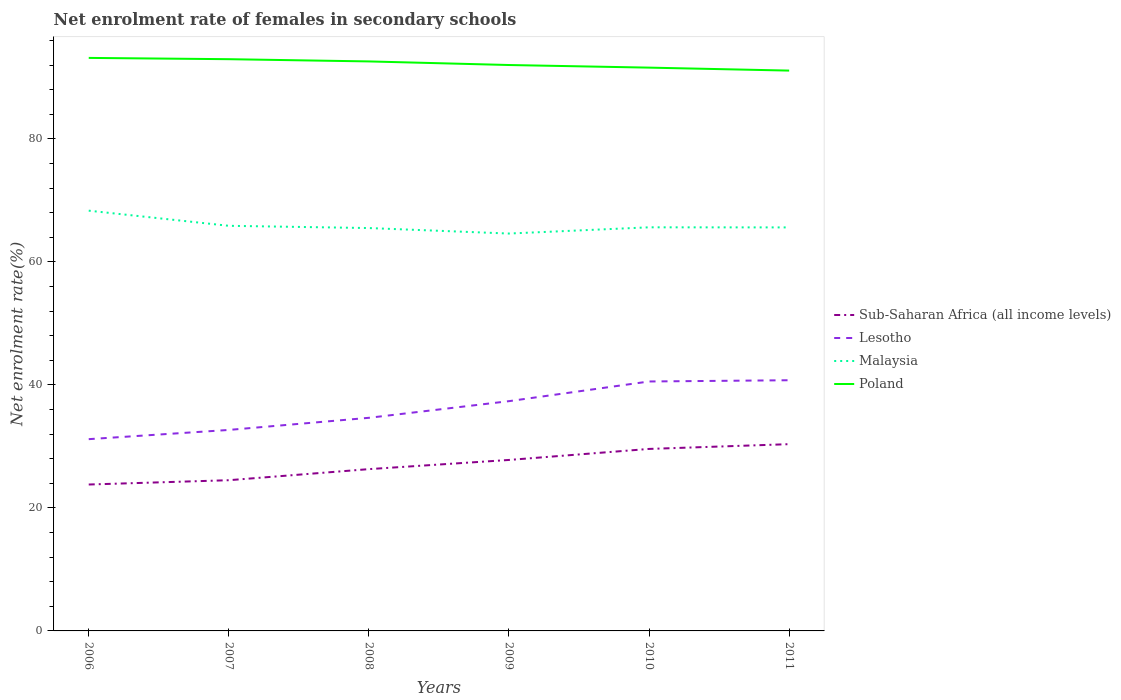How many different coloured lines are there?
Your answer should be very brief. 4. Is the number of lines equal to the number of legend labels?
Your answer should be compact. Yes. Across all years, what is the maximum net enrolment rate of females in secondary schools in Malaysia?
Keep it short and to the point. 64.6. What is the total net enrolment rate of females in secondary schools in Sub-Saharan Africa (all income levels) in the graph?
Your answer should be very brief. -1.49. What is the difference between the highest and the second highest net enrolment rate of females in secondary schools in Poland?
Your answer should be compact. 2.06. Is the net enrolment rate of females in secondary schools in Poland strictly greater than the net enrolment rate of females in secondary schools in Malaysia over the years?
Provide a succinct answer. No. Does the graph contain any zero values?
Give a very brief answer. No. Does the graph contain grids?
Provide a short and direct response. No. Where does the legend appear in the graph?
Provide a short and direct response. Center right. How many legend labels are there?
Keep it short and to the point. 4. What is the title of the graph?
Ensure brevity in your answer.  Net enrolment rate of females in secondary schools. What is the label or title of the X-axis?
Offer a terse response. Years. What is the label or title of the Y-axis?
Make the answer very short. Net enrolment rate(%). What is the Net enrolment rate(%) in Sub-Saharan Africa (all income levels) in 2006?
Your answer should be very brief. 23.8. What is the Net enrolment rate(%) in Lesotho in 2006?
Your answer should be very brief. 31.17. What is the Net enrolment rate(%) of Malaysia in 2006?
Your answer should be very brief. 68.32. What is the Net enrolment rate(%) of Poland in 2006?
Offer a terse response. 93.15. What is the Net enrolment rate(%) in Sub-Saharan Africa (all income levels) in 2007?
Offer a terse response. 24.5. What is the Net enrolment rate(%) of Lesotho in 2007?
Your answer should be compact. 32.67. What is the Net enrolment rate(%) in Malaysia in 2007?
Provide a short and direct response. 65.86. What is the Net enrolment rate(%) in Poland in 2007?
Your response must be concise. 92.95. What is the Net enrolment rate(%) of Sub-Saharan Africa (all income levels) in 2008?
Offer a very short reply. 26.3. What is the Net enrolment rate(%) of Lesotho in 2008?
Your answer should be compact. 34.65. What is the Net enrolment rate(%) in Malaysia in 2008?
Keep it short and to the point. 65.49. What is the Net enrolment rate(%) of Poland in 2008?
Provide a short and direct response. 92.58. What is the Net enrolment rate(%) of Sub-Saharan Africa (all income levels) in 2009?
Make the answer very short. 27.79. What is the Net enrolment rate(%) of Lesotho in 2009?
Your answer should be compact. 37.35. What is the Net enrolment rate(%) in Malaysia in 2009?
Ensure brevity in your answer.  64.6. What is the Net enrolment rate(%) in Poland in 2009?
Offer a very short reply. 92. What is the Net enrolment rate(%) in Sub-Saharan Africa (all income levels) in 2010?
Provide a succinct answer. 29.59. What is the Net enrolment rate(%) of Lesotho in 2010?
Your response must be concise. 40.55. What is the Net enrolment rate(%) of Malaysia in 2010?
Offer a very short reply. 65.61. What is the Net enrolment rate(%) in Poland in 2010?
Your answer should be very brief. 91.57. What is the Net enrolment rate(%) in Sub-Saharan Africa (all income levels) in 2011?
Keep it short and to the point. 30.36. What is the Net enrolment rate(%) in Lesotho in 2011?
Give a very brief answer. 40.75. What is the Net enrolment rate(%) of Malaysia in 2011?
Keep it short and to the point. 65.6. What is the Net enrolment rate(%) of Poland in 2011?
Your answer should be very brief. 91.09. Across all years, what is the maximum Net enrolment rate(%) in Sub-Saharan Africa (all income levels)?
Your answer should be very brief. 30.36. Across all years, what is the maximum Net enrolment rate(%) of Lesotho?
Your response must be concise. 40.75. Across all years, what is the maximum Net enrolment rate(%) of Malaysia?
Provide a short and direct response. 68.32. Across all years, what is the maximum Net enrolment rate(%) in Poland?
Provide a short and direct response. 93.15. Across all years, what is the minimum Net enrolment rate(%) in Sub-Saharan Africa (all income levels)?
Offer a very short reply. 23.8. Across all years, what is the minimum Net enrolment rate(%) in Lesotho?
Your answer should be very brief. 31.17. Across all years, what is the minimum Net enrolment rate(%) of Malaysia?
Ensure brevity in your answer.  64.6. Across all years, what is the minimum Net enrolment rate(%) in Poland?
Your answer should be compact. 91.09. What is the total Net enrolment rate(%) of Sub-Saharan Africa (all income levels) in the graph?
Make the answer very short. 162.35. What is the total Net enrolment rate(%) of Lesotho in the graph?
Offer a terse response. 217.15. What is the total Net enrolment rate(%) of Malaysia in the graph?
Make the answer very short. 395.48. What is the total Net enrolment rate(%) of Poland in the graph?
Give a very brief answer. 553.35. What is the difference between the Net enrolment rate(%) in Sub-Saharan Africa (all income levels) in 2006 and that in 2007?
Your answer should be very brief. -0.7. What is the difference between the Net enrolment rate(%) in Lesotho in 2006 and that in 2007?
Offer a terse response. -1.5. What is the difference between the Net enrolment rate(%) of Malaysia in 2006 and that in 2007?
Offer a terse response. 2.46. What is the difference between the Net enrolment rate(%) of Poland in 2006 and that in 2007?
Provide a short and direct response. 0.21. What is the difference between the Net enrolment rate(%) in Sub-Saharan Africa (all income levels) in 2006 and that in 2008?
Offer a terse response. -2.5. What is the difference between the Net enrolment rate(%) in Lesotho in 2006 and that in 2008?
Your answer should be compact. -3.47. What is the difference between the Net enrolment rate(%) in Malaysia in 2006 and that in 2008?
Your answer should be very brief. 2.83. What is the difference between the Net enrolment rate(%) of Poland in 2006 and that in 2008?
Give a very brief answer. 0.57. What is the difference between the Net enrolment rate(%) of Sub-Saharan Africa (all income levels) in 2006 and that in 2009?
Make the answer very short. -3.99. What is the difference between the Net enrolment rate(%) in Lesotho in 2006 and that in 2009?
Your answer should be very brief. -6.18. What is the difference between the Net enrolment rate(%) in Malaysia in 2006 and that in 2009?
Your response must be concise. 3.72. What is the difference between the Net enrolment rate(%) of Poland in 2006 and that in 2009?
Provide a succinct answer. 1.16. What is the difference between the Net enrolment rate(%) of Sub-Saharan Africa (all income levels) in 2006 and that in 2010?
Keep it short and to the point. -5.79. What is the difference between the Net enrolment rate(%) of Lesotho in 2006 and that in 2010?
Make the answer very short. -9.38. What is the difference between the Net enrolment rate(%) in Malaysia in 2006 and that in 2010?
Provide a succinct answer. 2.71. What is the difference between the Net enrolment rate(%) of Poland in 2006 and that in 2010?
Your answer should be compact. 1.58. What is the difference between the Net enrolment rate(%) of Sub-Saharan Africa (all income levels) in 2006 and that in 2011?
Your response must be concise. -6.56. What is the difference between the Net enrolment rate(%) in Lesotho in 2006 and that in 2011?
Offer a very short reply. -9.58. What is the difference between the Net enrolment rate(%) in Malaysia in 2006 and that in 2011?
Your response must be concise. 2.72. What is the difference between the Net enrolment rate(%) in Poland in 2006 and that in 2011?
Ensure brevity in your answer.  2.06. What is the difference between the Net enrolment rate(%) in Sub-Saharan Africa (all income levels) in 2007 and that in 2008?
Provide a succinct answer. -1.8. What is the difference between the Net enrolment rate(%) in Lesotho in 2007 and that in 2008?
Ensure brevity in your answer.  -1.97. What is the difference between the Net enrolment rate(%) in Malaysia in 2007 and that in 2008?
Ensure brevity in your answer.  0.37. What is the difference between the Net enrolment rate(%) in Poland in 2007 and that in 2008?
Your answer should be very brief. 0.36. What is the difference between the Net enrolment rate(%) of Sub-Saharan Africa (all income levels) in 2007 and that in 2009?
Make the answer very short. -3.29. What is the difference between the Net enrolment rate(%) of Lesotho in 2007 and that in 2009?
Your response must be concise. -4.68. What is the difference between the Net enrolment rate(%) in Malaysia in 2007 and that in 2009?
Ensure brevity in your answer.  1.26. What is the difference between the Net enrolment rate(%) of Poland in 2007 and that in 2009?
Provide a short and direct response. 0.95. What is the difference between the Net enrolment rate(%) of Sub-Saharan Africa (all income levels) in 2007 and that in 2010?
Provide a short and direct response. -5.09. What is the difference between the Net enrolment rate(%) of Lesotho in 2007 and that in 2010?
Your answer should be very brief. -7.88. What is the difference between the Net enrolment rate(%) in Malaysia in 2007 and that in 2010?
Make the answer very short. 0.25. What is the difference between the Net enrolment rate(%) in Poland in 2007 and that in 2010?
Your response must be concise. 1.37. What is the difference between the Net enrolment rate(%) of Sub-Saharan Africa (all income levels) in 2007 and that in 2011?
Keep it short and to the point. -5.86. What is the difference between the Net enrolment rate(%) of Lesotho in 2007 and that in 2011?
Your response must be concise. -8.08. What is the difference between the Net enrolment rate(%) of Malaysia in 2007 and that in 2011?
Your response must be concise. 0.26. What is the difference between the Net enrolment rate(%) of Poland in 2007 and that in 2011?
Your answer should be compact. 1.85. What is the difference between the Net enrolment rate(%) of Sub-Saharan Africa (all income levels) in 2008 and that in 2009?
Your answer should be very brief. -1.49. What is the difference between the Net enrolment rate(%) of Lesotho in 2008 and that in 2009?
Your answer should be compact. -2.71. What is the difference between the Net enrolment rate(%) of Malaysia in 2008 and that in 2009?
Your response must be concise. 0.89. What is the difference between the Net enrolment rate(%) of Poland in 2008 and that in 2009?
Offer a terse response. 0.58. What is the difference between the Net enrolment rate(%) in Sub-Saharan Africa (all income levels) in 2008 and that in 2010?
Offer a terse response. -3.28. What is the difference between the Net enrolment rate(%) of Lesotho in 2008 and that in 2010?
Your answer should be compact. -5.91. What is the difference between the Net enrolment rate(%) in Malaysia in 2008 and that in 2010?
Provide a succinct answer. -0.12. What is the difference between the Net enrolment rate(%) in Poland in 2008 and that in 2010?
Provide a short and direct response. 1.01. What is the difference between the Net enrolment rate(%) of Sub-Saharan Africa (all income levels) in 2008 and that in 2011?
Give a very brief answer. -4.06. What is the difference between the Net enrolment rate(%) of Lesotho in 2008 and that in 2011?
Your response must be concise. -6.11. What is the difference between the Net enrolment rate(%) in Malaysia in 2008 and that in 2011?
Keep it short and to the point. -0.1. What is the difference between the Net enrolment rate(%) of Poland in 2008 and that in 2011?
Your answer should be very brief. 1.49. What is the difference between the Net enrolment rate(%) in Sub-Saharan Africa (all income levels) in 2009 and that in 2010?
Ensure brevity in your answer.  -1.79. What is the difference between the Net enrolment rate(%) in Lesotho in 2009 and that in 2010?
Provide a short and direct response. -3.2. What is the difference between the Net enrolment rate(%) of Malaysia in 2009 and that in 2010?
Make the answer very short. -1.01. What is the difference between the Net enrolment rate(%) of Poland in 2009 and that in 2010?
Your response must be concise. 0.42. What is the difference between the Net enrolment rate(%) in Sub-Saharan Africa (all income levels) in 2009 and that in 2011?
Ensure brevity in your answer.  -2.57. What is the difference between the Net enrolment rate(%) of Lesotho in 2009 and that in 2011?
Your response must be concise. -3.4. What is the difference between the Net enrolment rate(%) in Malaysia in 2009 and that in 2011?
Your answer should be very brief. -1. What is the difference between the Net enrolment rate(%) in Poland in 2009 and that in 2011?
Your answer should be very brief. 0.91. What is the difference between the Net enrolment rate(%) in Sub-Saharan Africa (all income levels) in 2010 and that in 2011?
Provide a succinct answer. -0.78. What is the difference between the Net enrolment rate(%) of Lesotho in 2010 and that in 2011?
Offer a terse response. -0.2. What is the difference between the Net enrolment rate(%) of Malaysia in 2010 and that in 2011?
Make the answer very short. 0.02. What is the difference between the Net enrolment rate(%) in Poland in 2010 and that in 2011?
Make the answer very short. 0.48. What is the difference between the Net enrolment rate(%) in Sub-Saharan Africa (all income levels) in 2006 and the Net enrolment rate(%) in Lesotho in 2007?
Make the answer very short. -8.87. What is the difference between the Net enrolment rate(%) of Sub-Saharan Africa (all income levels) in 2006 and the Net enrolment rate(%) of Malaysia in 2007?
Keep it short and to the point. -42.06. What is the difference between the Net enrolment rate(%) of Sub-Saharan Africa (all income levels) in 2006 and the Net enrolment rate(%) of Poland in 2007?
Your answer should be compact. -69.14. What is the difference between the Net enrolment rate(%) of Lesotho in 2006 and the Net enrolment rate(%) of Malaysia in 2007?
Provide a succinct answer. -34.68. What is the difference between the Net enrolment rate(%) in Lesotho in 2006 and the Net enrolment rate(%) in Poland in 2007?
Your response must be concise. -61.77. What is the difference between the Net enrolment rate(%) of Malaysia in 2006 and the Net enrolment rate(%) of Poland in 2007?
Provide a short and direct response. -24.63. What is the difference between the Net enrolment rate(%) of Sub-Saharan Africa (all income levels) in 2006 and the Net enrolment rate(%) of Lesotho in 2008?
Your answer should be very brief. -10.85. What is the difference between the Net enrolment rate(%) in Sub-Saharan Africa (all income levels) in 2006 and the Net enrolment rate(%) in Malaysia in 2008?
Keep it short and to the point. -41.69. What is the difference between the Net enrolment rate(%) of Sub-Saharan Africa (all income levels) in 2006 and the Net enrolment rate(%) of Poland in 2008?
Offer a terse response. -68.78. What is the difference between the Net enrolment rate(%) in Lesotho in 2006 and the Net enrolment rate(%) in Malaysia in 2008?
Your response must be concise. -34.32. What is the difference between the Net enrolment rate(%) of Lesotho in 2006 and the Net enrolment rate(%) of Poland in 2008?
Your response must be concise. -61.41. What is the difference between the Net enrolment rate(%) in Malaysia in 2006 and the Net enrolment rate(%) in Poland in 2008?
Provide a succinct answer. -24.26. What is the difference between the Net enrolment rate(%) in Sub-Saharan Africa (all income levels) in 2006 and the Net enrolment rate(%) in Lesotho in 2009?
Provide a short and direct response. -13.55. What is the difference between the Net enrolment rate(%) of Sub-Saharan Africa (all income levels) in 2006 and the Net enrolment rate(%) of Malaysia in 2009?
Give a very brief answer. -40.8. What is the difference between the Net enrolment rate(%) in Sub-Saharan Africa (all income levels) in 2006 and the Net enrolment rate(%) in Poland in 2009?
Your response must be concise. -68.2. What is the difference between the Net enrolment rate(%) in Lesotho in 2006 and the Net enrolment rate(%) in Malaysia in 2009?
Give a very brief answer. -33.43. What is the difference between the Net enrolment rate(%) of Lesotho in 2006 and the Net enrolment rate(%) of Poland in 2009?
Your answer should be very brief. -60.82. What is the difference between the Net enrolment rate(%) in Malaysia in 2006 and the Net enrolment rate(%) in Poland in 2009?
Your response must be concise. -23.68. What is the difference between the Net enrolment rate(%) in Sub-Saharan Africa (all income levels) in 2006 and the Net enrolment rate(%) in Lesotho in 2010?
Your answer should be very brief. -16.75. What is the difference between the Net enrolment rate(%) of Sub-Saharan Africa (all income levels) in 2006 and the Net enrolment rate(%) of Malaysia in 2010?
Provide a succinct answer. -41.81. What is the difference between the Net enrolment rate(%) of Sub-Saharan Africa (all income levels) in 2006 and the Net enrolment rate(%) of Poland in 2010?
Offer a very short reply. -67.77. What is the difference between the Net enrolment rate(%) of Lesotho in 2006 and the Net enrolment rate(%) of Malaysia in 2010?
Provide a succinct answer. -34.44. What is the difference between the Net enrolment rate(%) of Lesotho in 2006 and the Net enrolment rate(%) of Poland in 2010?
Your answer should be compact. -60.4. What is the difference between the Net enrolment rate(%) in Malaysia in 2006 and the Net enrolment rate(%) in Poland in 2010?
Provide a short and direct response. -23.25. What is the difference between the Net enrolment rate(%) in Sub-Saharan Africa (all income levels) in 2006 and the Net enrolment rate(%) in Lesotho in 2011?
Keep it short and to the point. -16.95. What is the difference between the Net enrolment rate(%) in Sub-Saharan Africa (all income levels) in 2006 and the Net enrolment rate(%) in Malaysia in 2011?
Your response must be concise. -41.8. What is the difference between the Net enrolment rate(%) in Sub-Saharan Africa (all income levels) in 2006 and the Net enrolment rate(%) in Poland in 2011?
Your answer should be very brief. -67.29. What is the difference between the Net enrolment rate(%) of Lesotho in 2006 and the Net enrolment rate(%) of Malaysia in 2011?
Provide a short and direct response. -34.42. What is the difference between the Net enrolment rate(%) in Lesotho in 2006 and the Net enrolment rate(%) in Poland in 2011?
Provide a succinct answer. -59.92. What is the difference between the Net enrolment rate(%) in Malaysia in 2006 and the Net enrolment rate(%) in Poland in 2011?
Your answer should be compact. -22.77. What is the difference between the Net enrolment rate(%) in Sub-Saharan Africa (all income levels) in 2007 and the Net enrolment rate(%) in Lesotho in 2008?
Provide a succinct answer. -10.14. What is the difference between the Net enrolment rate(%) in Sub-Saharan Africa (all income levels) in 2007 and the Net enrolment rate(%) in Malaysia in 2008?
Your response must be concise. -40.99. What is the difference between the Net enrolment rate(%) in Sub-Saharan Africa (all income levels) in 2007 and the Net enrolment rate(%) in Poland in 2008?
Offer a terse response. -68.08. What is the difference between the Net enrolment rate(%) of Lesotho in 2007 and the Net enrolment rate(%) of Malaysia in 2008?
Provide a succinct answer. -32.82. What is the difference between the Net enrolment rate(%) in Lesotho in 2007 and the Net enrolment rate(%) in Poland in 2008?
Keep it short and to the point. -59.91. What is the difference between the Net enrolment rate(%) in Malaysia in 2007 and the Net enrolment rate(%) in Poland in 2008?
Your answer should be compact. -26.72. What is the difference between the Net enrolment rate(%) of Sub-Saharan Africa (all income levels) in 2007 and the Net enrolment rate(%) of Lesotho in 2009?
Your answer should be compact. -12.85. What is the difference between the Net enrolment rate(%) of Sub-Saharan Africa (all income levels) in 2007 and the Net enrolment rate(%) of Malaysia in 2009?
Your answer should be very brief. -40.1. What is the difference between the Net enrolment rate(%) in Sub-Saharan Africa (all income levels) in 2007 and the Net enrolment rate(%) in Poland in 2009?
Ensure brevity in your answer.  -67.5. What is the difference between the Net enrolment rate(%) of Lesotho in 2007 and the Net enrolment rate(%) of Malaysia in 2009?
Keep it short and to the point. -31.93. What is the difference between the Net enrolment rate(%) in Lesotho in 2007 and the Net enrolment rate(%) in Poland in 2009?
Provide a succinct answer. -59.32. What is the difference between the Net enrolment rate(%) of Malaysia in 2007 and the Net enrolment rate(%) of Poland in 2009?
Provide a succinct answer. -26.14. What is the difference between the Net enrolment rate(%) of Sub-Saharan Africa (all income levels) in 2007 and the Net enrolment rate(%) of Lesotho in 2010?
Provide a succinct answer. -16.05. What is the difference between the Net enrolment rate(%) of Sub-Saharan Africa (all income levels) in 2007 and the Net enrolment rate(%) of Malaysia in 2010?
Your answer should be very brief. -41.11. What is the difference between the Net enrolment rate(%) of Sub-Saharan Africa (all income levels) in 2007 and the Net enrolment rate(%) of Poland in 2010?
Provide a short and direct response. -67.07. What is the difference between the Net enrolment rate(%) of Lesotho in 2007 and the Net enrolment rate(%) of Malaysia in 2010?
Make the answer very short. -32.94. What is the difference between the Net enrolment rate(%) in Lesotho in 2007 and the Net enrolment rate(%) in Poland in 2010?
Your answer should be very brief. -58.9. What is the difference between the Net enrolment rate(%) of Malaysia in 2007 and the Net enrolment rate(%) of Poland in 2010?
Offer a terse response. -25.71. What is the difference between the Net enrolment rate(%) of Sub-Saharan Africa (all income levels) in 2007 and the Net enrolment rate(%) of Lesotho in 2011?
Offer a very short reply. -16.25. What is the difference between the Net enrolment rate(%) of Sub-Saharan Africa (all income levels) in 2007 and the Net enrolment rate(%) of Malaysia in 2011?
Keep it short and to the point. -41.1. What is the difference between the Net enrolment rate(%) in Sub-Saharan Africa (all income levels) in 2007 and the Net enrolment rate(%) in Poland in 2011?
Offer a very short reply. -66.59. What is the difference between the Net enrolment rate(%) of Lesotho in 2007 and the Net enrolment rate(%) of Malaysia in 2011?
Keep it short and to the point. -32.92. What is the difference between the Net enrolment rate(%) of Lesotho in 2007 and the Net enrolment rate(%) of Poland in 2011?
Provide a succinct answer. -58.42. What is the difference between the Net enrolment rate(%) of Malaysia in 2007 and the Net enrolment rate(%) of Poland in 2011?
Offer a very short reply. -25.23. What is the difference between the Net enrolment rate(%) of Sub-Saharan Africa (all income levels) in 2008 and the Net enrolment rate(%) of Lesotho in 2009?
Your response must be concise. -11.05. What is the difference between the Net enrolment rate(%) in Sub-Saharan Africa (all income levels) in 2008 and the Net enrolment rate(%) in Malaysia in 2009?
Give a very brief answer. -38.3. What is the difference between the Net enrolment rate(%) in Sub-Saharan Africa (all income levels) in 2008 and the Net enrolment rate(%) in Poland in 2009?
Offer a terse response. -65.7. What is the difference between the Net enrolment rate(%) of Lesotho in 2008 and the Net enrolment rate(%) of Malaysia in 2009?
Your answer should be compact. -29.96. What is the difference between the Net enrolment rate(%) of Lesotho in 2008 and the Net enrolment rate(%) of Poland in 2009?
Offer a very short reply. -57.35. What is the difference between the Net enrolment rate(%) in Malaysia in 2008 and the Net enrolment rate(%) in Poland in 2009?
Offer a terse response. -26.5. What is the difference between the Net enrolment rate(%) of Sub-Saharan Africa (all income levels) in 2008 and the Net enrolment rate(%) of Lesotho in 2010?
Provide a succinct answer. -14.25. What is the difference between the Net enrolment rate(%) in Sub-Saharan Africa (all income levels) in 2008 and the Net enrolment rate(%) in Malaysia in 2010?
Offer a very short reply. -39.31. What is the difference between the Net enrolment rate(%) of Sub-Saharan Africa (all income levels) in 2008 and the Net enrolment rate(%) of Poland in 2010?
Make the answer very short. -65.27. What is the difference between the Net enrolment rate(%) of Lesotho in 2008 and the Net enrolment rate(%) of Malaysia in 2010?
Your response must be concise. -30.97. What is the difference between the Net enrolment rate(%) of Lesotho in 2008 and the Net enrolment rate(%) of Poland in 2010?
Offer a very short reply. -56.93. What is the difference between the Net enrolment rate(%) in Malaysia in 2008 and the Net enrolment rate(%) in Poland in 2010?
Your answer should be very brief. -26.08. What is the difference between the Net enrolment rate(%) in Sub-Saharan Africa (all income levels) in 2008 and the Net enrolment rate(%) in Lesotho in 2011?
Keep it short and to the point. -14.45. What is the difference between the Net enrolment rate(%) of Sub-Saharan Africa (all income levels) in 2008 and the Net enrolment rate(%) of Malaysia in 2011?
Ensure brevity in your answer.  -39.3. What is the difference between the Net enrolment rate(%) in Sub-Saharan Africa (all income levels) in 2008 and the Net enrolment rate(%) in Poland in 2011?
Offer a very short reply. -64.79. What is the difference between the Net enrolment rate(%) in Lesotho in 2008 and the Net enrolment rate(%) in Malaysia in 2011?
Your answer should be very brief. -30.95. What is the difference between the Net enrolment rate(%) in Lesotho in 2008 and the Net enrolment rate(%) in Poland in 2011?
Offer a very short reply. -56.45. What is the difference between the Net enrolment rate(%) in Malaysia in 2008 and the Net enrolment rate(%) in Poland in 2011?
Ensure brevity in your answer.  -25.6. What is the difference between the Net enrolment rate(%) of Sub-Saharan Africa (all income levels) in 2009 and the Net enrolment rate(%) of Lesotho in 2010?
Offer a very short reply. -12.76. What is the difference between the Net enrolment rate(%) in Sub-Saharan Africa (all income levels) in 2009 and the Net enrolment rate(%) in Malaysia in 2010?
Your answer should be very brief. -37.82. What is the difference between the Net enrolment rate(%) of Sub-Saharan Africa (all income levels) in 2009 and the Net enrolment rate(%) of Poland in 2010?
Make the answer very short. -63.78. What is the difference between the Net enrolment rate(%) in Lesotho in 2009 and the Net enrolment rate(%) in Malaysia in 2010?
Give a very brief answer. -28.26. What is the difference between the Net enrolment rate(%) in Lesotho in 2009 and the Net enrolment rate(%) in Poland in 2010?
Provide a short and direct response. -54.22. What is the difference between the Net enrolment rate(%) in Malaysia in 2009 and the Net enrolment rate(%) in Poland in 2010?
Ensure brevity in your answer.  -26.97. What is the difference between the Net enrolment rate(%) of Sub-Saharan Africa (all income levels) in 2009 and the Net enrolment rate(%) of Lesotho in 2011?
Ensure brevity in your answer.  -12.96. What is the difference between the Net enrolment rate(%) in Sub-Saharan Africa (all income levels) in 2009 and the Net enrolment rate(%) in Malaysia in 2011?
Your answer should be very brief. -37.8. What is the difference between the Net enrolment rate(%) of Sub-Saharan Africa (all income levels) in 2009 and the Net enrolment rate(%) of Poland in 2011?
Offer a very short reply. -63.3. What is the difference between the Net enrolment rate(%) in Lesotho in 2009 and the Net enrolment rate(%) in Malaysia in 2011?
Offer a terse response. -28.25. What is the difference between the Net enrolment rate(%) in Lesotho in 2009 and the Net enrolment rate(%) in Poland in 2011?
Your answer should be very brief. -53.74. What is the difference between the Net enrolment rate(%) in Malaysia in 2009 and the Net enrolment rate(%) in Poland in 2011?
Make the answer very short. -26.49. What is the difference between the Net enrolment rate(%) in Sub-Saharan Africa (all income levels) in 2010 and the Net enrolment rate(%) in Lesotho in 2011?
Ensure brevity in your answer.  -11.17. What is the difference between the Net enrolment rate(%) in Sub-Saharan Africa (all income levels) in 2010 and the Net enrolment rate(%) in Malaysia in 2011?
Keep it short and to the point. -36.01. What is the difference between the Net enrolment rate(%) of Sub-Saharan Africa (all income levels) in 2010 and the Net enrolment rate(%) of Poland in 2011?
Offer a terse response. -61.51. What is the difference between the Net enrolment rate(%) in Lesotho in 2010 and the Net enrolment rate(%) in Malaysia in 2011?
Ensure brevity in your answer.  -25.05. What is the difference between the Net enrolment rate(%) of Lesotho in 2010 and the Net enrolment rate(%) of Poland in 2011?
Keep it short and to the point. -50.54. What is the difference between the Net enrolment rate(%) of Malaysia in 2010 and the Net enrolment rate(%) of Poland in 2011?
Your answer should be very brief. -25.48. What is the average Net enrolment rate(%) of Sub-Saharan Africa (all income levels) per year?
Make the answer very short. 27.06. What is the average Net enrolment rate(%) in Lesotho per year?
Offer a terse response. 36.19. What is the average Net enrolment rate(%) in Malaysia per year?
Provide a short and direct response. 65.91. What is the average Net enrolment rate(%) of Poland per year?
Give a very brief answer. 92.22. In the year 2006, what is the difference between the Net enrolment rate(%) in Sub-Saharan Africa (all income levels) and Net enrolment rate(%) in Lesotho?
Your answer should be compact. -7.37. In the year 2006, what is the difference between the Net enrolment rate(%) in Sub-Saharan Africa (all income levels) and Net enrolment rate(%) in Malaysia?
Provide a succinct answer. -44.52. In the year 2006, what is the difference between the Net enrolment rate(%) of Sub-Saharan Africa (all income levels) and Net enrolment rate(%) of Poland?
Offer a very short reply. -69.35. In the year 2006, what is the difference between the Net enrolment rate(%) in Lesotho and Net enrolment rate(%) in Malaysia?
Make the answer very short. -37.14. In the year 2006, what is the difference between the Net enrolment rate(%) of Lesotho and Net enrolment rate(%) of Poland?
Make the answer very short. -61.98. In the year 2006, what is the difference between the Net enrolment rate(%) of Malaysia and Net enrolment rate(%) of Poland?
Your answer should be compact. -24.83. In the year 2007, what is the difference between the Net enrolment rate(%) in Sub-Saharan Africa (all income levels) and Net enrolment rate(%) in Lesotho?
Ensure brevity in your answer.  -8.17. In the year 2007, what is the difference between the Net enrolment rate(%) in Sub-Saharan Africa (all income levels) and Net enrolment rate(%) in Malaysia?
Give a very brief answer. -41.36. In the year 2007, what is the difference between the Net enrolment rate(%) of Sub-Saharan Africa (all income levels) and Net enrolment rate(%) of Poland?
Offer a very short reply. -68.44. In the year 2007, what is the difference between the Net enrolment rate(%) in Lesotho and Net enrolment rate(%) in Malaysia?
Your answer should be very brief. -33.19. In the year 2007, what is the difference between the Net enrolment rate(%) of Lesotho and Net enrolment rate(%) of Poland?
Offer a terse response. -60.27. In the year 2007, what is the difference between the Net enrolment rate(%) in Malaysia and Net enrolment rate(%) in Poland?
Provide a short and direct response. -27.09. In the year 2008, what is the difference between the Net enrolment rate(%) in Sub-Saharan Africa (all income levels) and Net enrolment rate(%) in Lesotho?
Make the answer very short. -8.34. In the year 2008, what is the difference between the Net enrolment rate(%) of Sub-Saharan Africa (all income levels) and Net enrolment rate(%) of Malaysia?
Provide a short and direct response. -39.19. In the year 2008, what is the difference between the Net enrolment rate(%) of Sub-Saharan Africa (all income levels) and Net enrolment rate(%) of Poland?
Offer a terse response. -66.28. In the year 2008, what is the difference between the Net enrolment rate(%) of Lesotho and Net enrolment rate(%) of Malaysia?
Provide a succinct answer. -30.85. In the year 2008, what is the difference between the Net enrolment rate(%) in Lesotho and Net enrolment rate(%) in Poland?
Your answer should be very brief. -57.94. In the year 2008, what is the difference between the Net enrolment rate(%) in Malaysia and Net enrolment rate(%) in Poland?
Offer a very short reply. -27.09. In the year 2009, what is the difference between the Net enrolment rate(%) of Sub-Saharan Africa (all income levels) and Net enrolment rate(%) of Lesotho?
Provide a short and direct response. -9.56. In the year 2009, what is the difference between the Net enrolment rate(%) of Sub-Saharan Africa (all income levels) and Net enrolment rate(%) of Malaysia?
Ensure brevity in your answer.  -36.81. In the year 2009, what is the difference between the Net enrolment rate(%) in Sub-Saharan Africa (all income levels) and Net enrolment rate(%) in Poland?
Offer a very short reply. -64.2. In the year 2009, what is the difference between the Net enrolment rate(%) of Lesotho and Net enrolment rate(%) of Malaysia?
Offer a very short reply. -27.25. In the year 2009, what is the difference between the Net enrolment rate(%) of Lesotho and Net enrolment rate(%) of Poland?
Your response must be concise. -54.65. In the year 2009, what is the difference between the Net enrolment rate(%) in Malaysia and Net enrolment rate(%) in Poland?
Provide a succinct answer. -27.4. In the year 2010, what is the difference between the Net enrolment rate(%) in Sub-Saharan Africa (all income levels) and Net enrolment rate(%) in Lesotho?
Keep it short and to the point. -10.97. In the year 2010, what is the difference between the Net enrolment rate(%) in Sub-Saharan Africa (all income levels) and Net enrolment rate(%) in Malaysia?
Offer a very short reply. -36.03. In the year 2010, what is the difference between the Net enrolment rate(%) in Sub-Saharan Africa (all income levels) and Net enrolment rate(%) in Poland?
Make the answer very short. -61.99. In the year 2010, what is the difference between the Net enrolment rate(%) of Lesotho and Net enrolment rate(%) of Malaysia?
Give a very brief answer. -25.06. In the year 2010, what is the difference between the Net enrolment rate(%) of Lesotho and Net enrolment rate(%) of Poland?
Offer a very short reply. -51.02. In the year 2010, what is the difference between the Net enrolment rate(%) in Malaysia and Net enrolment rate(%) in Poland?
Make the answer very short. -25.96. In the year 2011, what is the difference between the Net enrolment rate(%) of Sub-Saharan Africa (all income levels) and Net enrolment rate(%) of Lesotho?
Your answer should be very brief. -10.39. In the year 2011, what is the difference between the Net enrolment rate(%) in Sub-Saharan Africa (all income levels) and Net enrolment rate(%) in Malaysia?
Offer a terse response. -35.24. In the year 2011, what is the difference between the Net enrolment rate(%) in Sub-Saharan Africa (all income levels) and Net enrolment rate(%) in Poland?
Your answer should be compact. -60.73. In the year 2011, what is the difference between the Net enrolment rate(%) of Lesotho and Net enrolment rate(%) of Malaysia?
Provide a short and direct response. -24.84. In the year 2011, what is the difference between the Net enrolment rate(%) in Lesotho and Net enrolment rate(%) in Poland?
Give a very brief answer. -50.34. In the year 2011, what is the difference between the Net enrolment rate(%) of Malaysia and Net enrolment rate(%) of Poland?
Make the answer very short. -25.49. What is the ratio of the Net enrolment rate(%) of Sub-Saharan Africa (all income levels) in 2006 to that in 2007?
Make the answer very short. 0.97. What is the ratio of the Net enrolment rate(%) in Lesotho in 2006 to that in 2007?
Make the answer very short. 0.95. What is the ratio of the Net enrolment rate(%) in Malaysia in 2006 to that in 2007?
Offer a terse response. 1.04. What is the ratio of the Net enrolment rate(%) of Sub-Saharan Africa (all income levels) in 2006 to that in 2008?
Your response must be concise. 0.9. What is the ratio of the Net enrolment rate(%) in Lesotho in 2006 to that in 2008?
Your answer should be compact. 0.9. What is the ratio of the Net enrolment rate(%) in Malaysia in 2006 to that in 2008?
Your answer should be compact. 1.04. What is the ratio of the Net enrolment rate(%) of Poland in 2006 to that in 2008?
Your response must be concise. 1.01. What is the ratio of the Net enrolment rate(%) of Sub-Saharan Africa (all income levels) in 2006 to that in 2009?
Provide a succinct answer. 0.86. What is the ratio of the Net enrolment rate(%) in Lesotho in 2006 to that in 2009?
Your answer should be very brief. 0.83. What is the ratio of the Net enrolment rate(%) in Malaysia in 2006 to that in 2009?
Keep it short and to the point. 1.06. What is the ratio of the Net enrolment rate(%) of Poland in 2006 to that in 2009?
Keep it short and to the point. 1.01. What is the ratio of the Net enrolment rate(%) of Sub-Saharan Africa (all income levels) in 2006 to that in 2010?
Your response must be concise. 0.8. What is the ratio of the Net enrolment rate(%) of Lesotho in 2006 to that in 2010?
Make the answer very short. 0.77. What is the ratio of the Net enrolment rate(%) of Malaysia in 2006 to that in 2010?
Your answer should be compact. 1.04. What is the ratio of the Net enrolment rate(%) in Poland in 2006 to that in 2010?
Your answer should be compact. 1.02. What is the ratio of the Net enrolment rate(%) in Sub-Saharan Africa (all income levels) in 2006 to that in 2011?
Give a very brief answer. 0.78. What is the ratio of the Net enrolment rate(%) in Lesotho in 2006 to that in 2011?
Keep it short and to the point. 0.77. What is the ratio of the Net enrolment rate(%) in Malaysia in 2006 to that in 2011?
Offer a very short reply. 1.04. What is the ratio of the Net enrolment rate(%) of Poland in 2006 to that in 2011?
Offer a very short reply. 1.02. What is the ratio of the Net enrolment rate(%) in Sub-Saharan Africa (all income levels) in 2007 to that in 2008?
Your answer should be very brief. 0.93. What is the ratio of the Net enrolment rate(%) of Lesotho in 2007 to that in 2008?
Offer a terse response. 0.94. What is the ratio of the Net enrolment rate(%) in Malaysia in 2007 to that in 2008?
Provide a short and direct response. 1.01. What is the ratio of the Net enrolment rate(%) of Poland in 2007 to that in 2008?
Keep it short and to the point. 1. What is the ratio of the Net enrolment rate(%) in Sub-Saharan Africa (all income levels) in 2007 to that in 2009?
Give a very brief answer. 0.88. What is the ratio of the Net enrolment rate(%) of Lesotho in 2007 to that in 2009?
Ensure brevity in your answer.  0.87. What is the ratio of the Net enrolment rate(%) in Malaysia in 2007 to that in 2009?
Offer a very short reply. 1.02. What is the ratio of the Net enrolment rate(%) in Poland in 2007 to that in 2009?
Keep it short and to the point. 1.01. What is the ratio of the Net enrolment rate(%) in Sub-Saharan Africa (all income levels) in 2007 to that in 2010?
Offer a terse response. 0.83. What is the ratio of the Net enrolment rate(%) of Lesotho in 2007 to that in 2010?
Keep it short and to the point. 0.81. What is the ratio of the Net enrolment rate(%) of Sub-Saharan Africa (all income levels) in 2007 to that in 2011?
Your response must be concise. 0.81. What is the ratio of the Net enrolment rate(%) of Lesotho in 2007 to that in 2011?
Provide a succinct answer. 0.8. What is the ratio of the Net enrolment rate(%) in Poland in 2007 to that in 2011?
Your answer should be very brief. 1.02. What is the ratio of the Net enrolment rate(%) of Sub-Saharan Africa (all income levels) in 2008 to that in 2009?
Provide a succinct answer. 0.95. What is the ratio of the Net enrolment rate(%) in Lesotho in 2008 to that in 2009?
Offer a very short reply. 0.93. What is the ratio of the Net enrolment rate(%) of Malaysia in 2008 to that in 2009?
Give a very brief answer. 1.01. What is the ratio of the Net enrolment rate(%) in Poland in 2008 to that in 2009?
Your answer should be very brief. 1.01. What is the ratio of the Net enrolment rate(%) of Sub-Saharan Africa (all income levels) in 2008 to that in 2010?
Your response must be concise. 0.89. What is the ratio of the Net enrolment rate(%) of Lesotho in 2008 to that in 2010?
Provide a succinct answer. 0.85. What is the ratio of the Net enrolment rate(%) of Malaysia in 2008 to that in 2010?
Your answer should be compact. 1. What is the ratio of the Net enrolment rate(%) of Poland in 2008 to that in 2010?
Offer a very short reply. 1.01. What is the ratio of the Net enrolment rate(%) in Sub-Saharan Africa (all income levels) in 2008 to that in 2011?
Provide a short and direct response. 0.87. What is the ratio of the Net enrolment rate(%) in Lesotho in 2008 to that in 2011?
Provide a short and direct response. 0.85. What is the ratio of the Net enrolment rate(%) of Poland in 2008 to that in 2011?
Offer a very short reply. 1.02. What is the ratio of the Net enrolment rate(%) of Sub-Saharan Africa (all income levels) in 2009 to that in 2010?
Offer a very short reply. 0.94. What is the ratio of the Net enrolment rate(%) of Lesotho in 2009 to that in 2010?
Offer a terse response. 0.92. What is the ratio of the Net enrolment rate(%) in Malaysia in 2009 to that in 2010?
Offer a very short reply. 0.98. What is the ratio of the Net enrolment rate(%) in Poland in 2009 to that in 2010?
Offer a very short reply. 1. What is the ratio of the Net enrolment rate(%) of Sub-Saharan Africa (all income levels) in 2009 to that in 2011?
Provide a short and direct response. 0.92. What is the ratio of the Net enrolment rate(%) of Lesotho in 2009 to that in 2011?
Your answer should be compact. 0.92. What is the ratio of the Net enrolment rate(%) in Malaysia in 2009 to that in 2011?
Your answer should be compact. 0.98. What is the ratio of the Net enrolment rate(%) of Poland in 2009 to that in 2011?
Offer a very short reply. 1.01. What is the ratio of the Net enrolment rate(%) in Sub-Saharan Africa (all income levels) in 2010 to that in 2011?
Offer a terse response. 0.97. What is the difference between the highest and the second highest Net enrolment rate(%) in Sub-Saharan Africa (all income levels)?
Provide a short and direct response. 0.78. What is the difference between the highest and the second highest Net enrolment rate(%) in Lesotho?
Provide a succinct answer. 0.2. What is the difference between the highest and the second highest Net enrolment rate(%) in Malaysia?
Provide a succinct answer. 2.46. What is the difference between the highest and the second highest Net enrolment rate(%) of Poland?
Keep it short and to the point. 0.21. What is the difference between the highest and the lowest Net enrolment rate(%) of Sub-Saharan Africa (all income levels)?
Keep it short and to the point. 6.56. What is the difference between the highest and the lowest Net enrolment rate(%) in Lesotho?
Ensure brevity in your answer.  9.58. What is the difference between the highest and the lowest Net enrolment rate(%) of Malaysia?
Give a very brief answer. 3.72. What is the difference between the highest and the lowest Net enrolment rate(%) in Poland?
Make the answer very short. 2.06. 